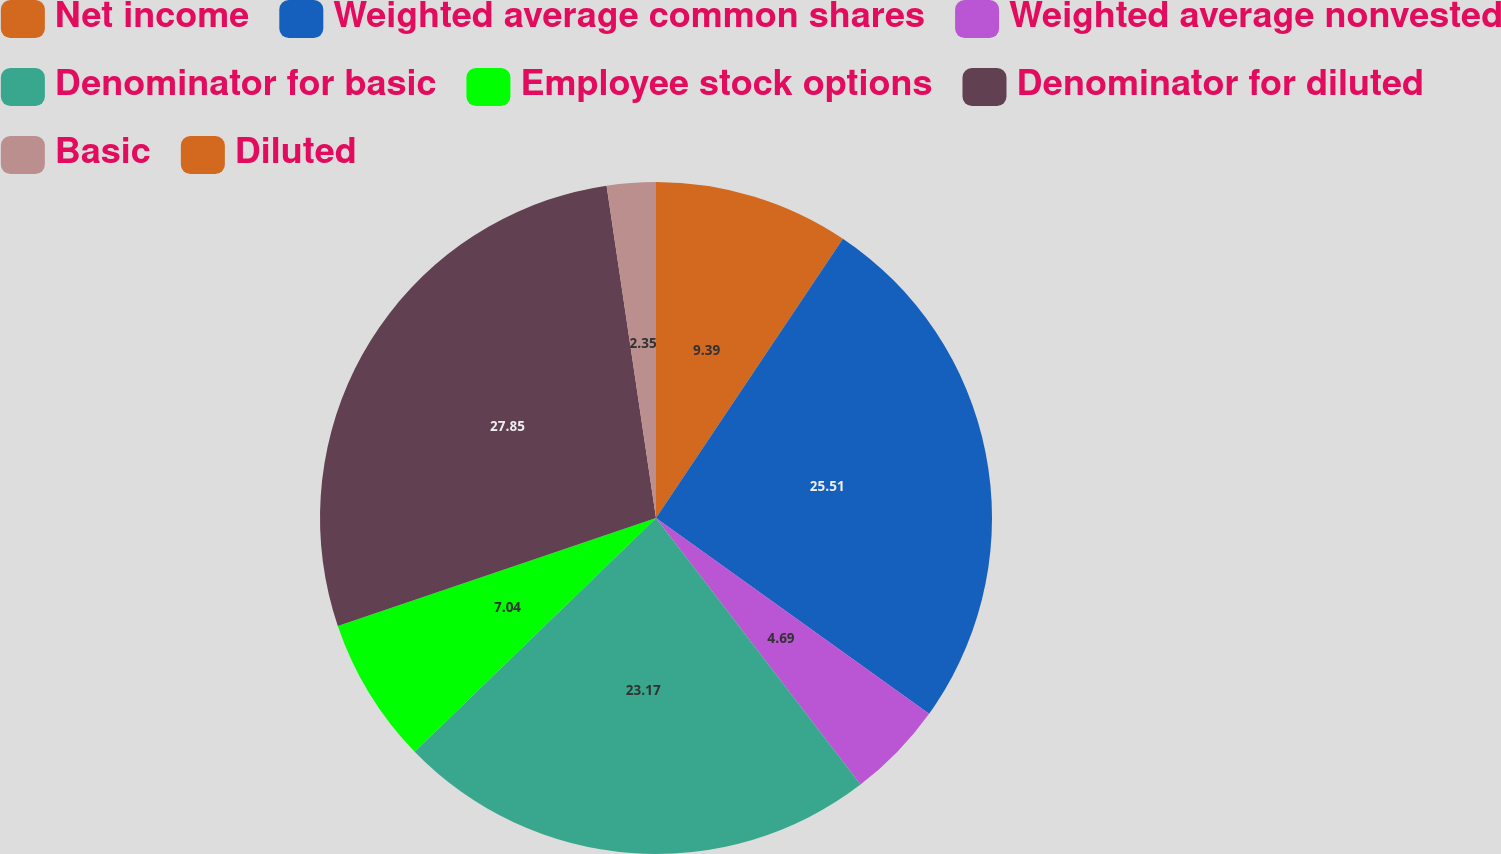<chart> <loc_0><loc_0><loc_500><loc_500><pie_chart><fcel>Net income<fcel>Weighted average common shares<fcel>Weighted average nonvested<fcel>Denominator for basic<fcel>Employee stock options<fcel>Denominator for diluted<fcel>Basic<fcel>Diluted<nl><fcel>9.39%<fcel>25.51%<fcel>4.69%<fcel>23.17%<fcel>7.04%<fcel>27.86%<fcel>2.35%<fcel>0.0%<nl></chart> 